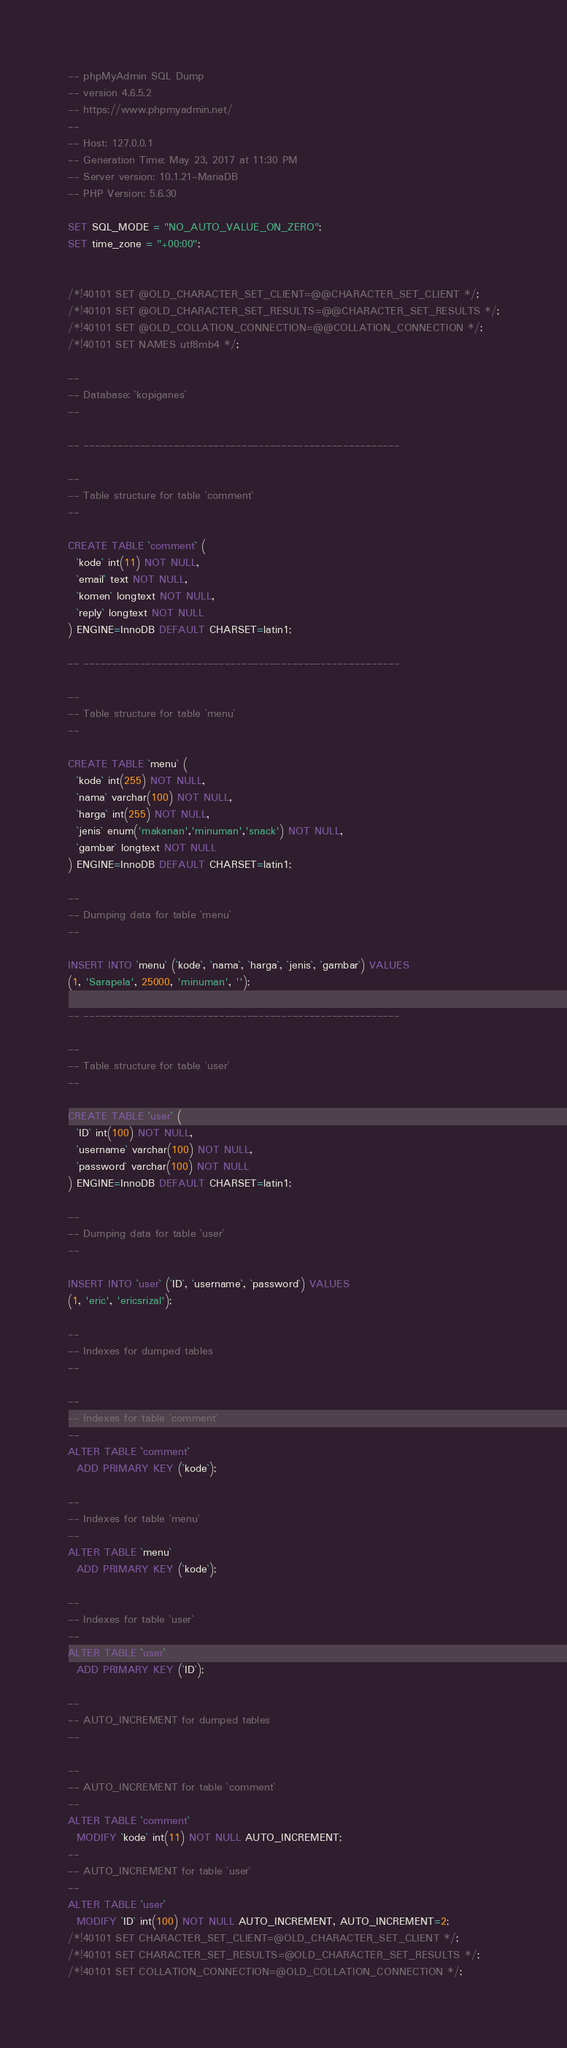<code> <loc_0><loc_0><loc_500><loc_500><_SQL_>-- phpMyAdmin SQL Dump
-- version 4.6.5.2
-- https://www.phpmyadmin.net/
--
-- Host: 127.0.0.1
-- Generation Time: May 23, 2017 at 11:30 PM
-- Server version: 10.1.21-MariaDB
-- PHP Version: 5.6.30

SET SQL_MODE = "NO_AUTO_VALUE_ON_ZERO";
SET time_zone = "+00:00";


/*!40101 SET @OLD_CHARACTER_SET_CLIENT=@@CHARACTER_SET_CLIENT */;
/*!40101 SET @OLD_CHARACTER_SET_RESULTS=@@CHARACTER_SET_RESULTS */;
/*!40101 SET @OLD_COLLATION_CONNECTION=@@COLLATION_CONNECTION */;
/*!40101 SET NAMES utf8mb4 */;

--
-- Database: `kopiganes`
--

-- --------------------------------------------------------

--
-- Table structure for table `comment`
--

CREATE TABLE `comment` (
  `kode` int(11) NOT NULL,
  `email` text NOT NULL,
  `komen` longtext NOT NULL,
  `reply` longtext NOT NULL
) ENGINE=InnoDB DEFAULT CHARSET=latin1;

-- --------------------------------------------------------

--
-- Table structure for table `menu`
--

CREATE TABLE `menu` (
  `kode` int(255) NOT NULL,
  `nama` varchar(100) NOT NULL,
  `harga` int(255) NOT NULL,
  `jenis` enum('makanan','minuman','snack') NOT NULL,
  `gambar` longtext NOT NULL
) ENGINE=InnoDB DEFAULT CHARSET=latin1;

--
-- Dumping data for table `menu`
--

INSERT INTO `menu` (`kode`, `nama`, `harga`, `jenis`, `gambar`) VALUES
(1, 'Sarapela', 25000, 'minuman', '');

-- --------------------------------------------------------

--
-- Table structure for table `user`
--

CREATE TABLE `user` (
  `ID` int(100) NOT NULL,
  `username` varchar(100) NOT NULL,
  `password` varchar(100) NOT NULL
) ENGINE=InnoDB DEFAULT CHARSET=latin1;

--
-- Dumping data for table `user`
--

INSERT INTO `user` (`ID`, `username`, `password`) VALUES
(1, 'eric', 'ericsrizal');

--
-- Indexes for dumped tables
--

--
-- Indexes for table `comment`
--
ALTER TABLE `comment`
  ADD PRIMARY KEY (`kode`);

--
-- Indexes for table `menu`
--
ALTER TABLE `menu`
  ADD PRIMARY KEY (`kode`);

--
-- Indexes for table `user`
--
ALTER TABLE `user`
  ADD PRIMARY KEY (`ID`);

--
-- AUTO_INCREMENT for dumped tables
--

--
-- AUTO_INCREMENT for table `comment`
--
ALTER TABLE `comment`
  MODIFY `kode` int(11) NOT NULL AUTO_INCREMENT;
--
-- AUTO_INCREMENT for table `user`
--
ALTER TABLE `user`
  MODIFY `ID` int(100) NOT NULL AUTO_INCREMENT, AUTO_INCREMENT=2;
/*!40101 SET CHARACTER_SET_CLIENT=@OLD_CHARACTER_SET_CLIENT */;
/*!40101 SET CHARACTER_SET_RESULTS=@OLD_CHARACTER_SET_RESULTS */;
/*!40101 SET COLLATION_CONNECTION=@OLD_COLLATION_CONNECTION */;
</code> 